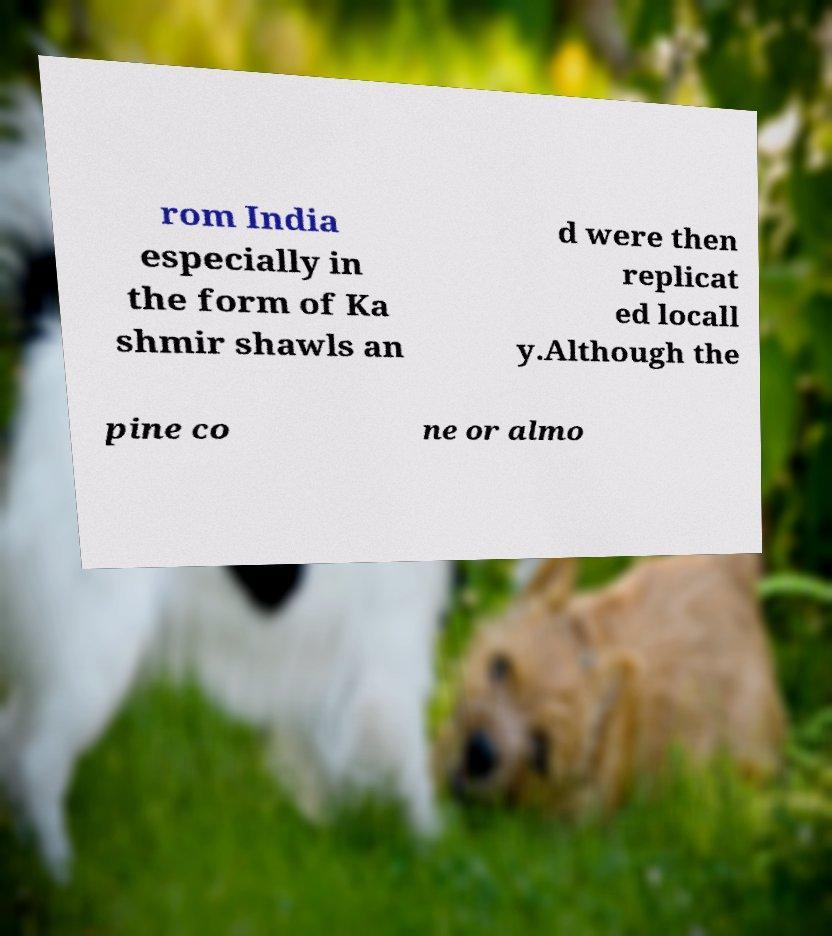For documentation purposes, I need the text within this image transcribed. Could you provide that? rom India especially in the form of Ka shmir shawls an d were then replicat ed locall y.Although the pine co ne or almo 